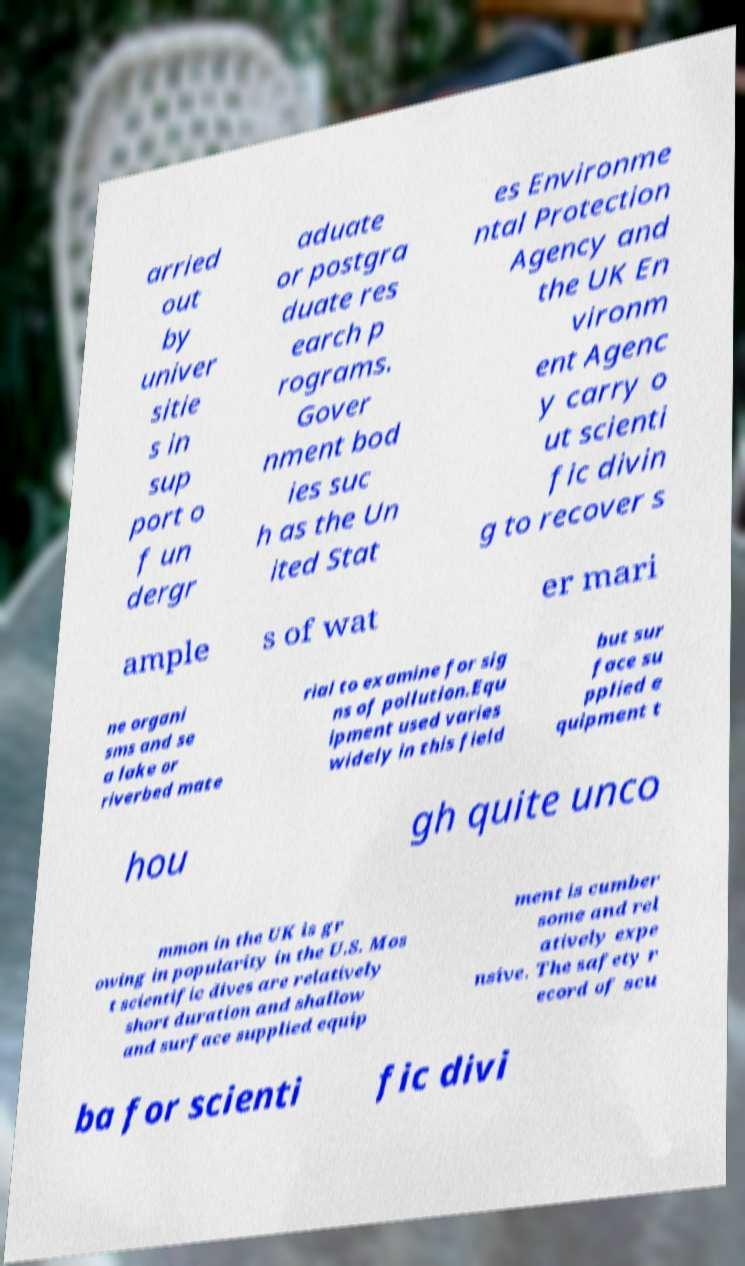Can you read and provide the text displayed in the image?This photo seems to have some interesting text. Can you extract and type it out for me? arried out by univer sitie s in sup port o f un dergr aduate or postgra duate res earch p rograms. Gover nment bod ies suc h as the Un ited Stat es Environme ntal Protection Agency and the UK En vironm ent Agenc y carry o ut scienti fic divin g to recover s ample s of wat er mari ne organi sms and se a lake or riverbed mate rial to examine for sig ns of pollution.Equ ipment used varies widely in this field but sur face su pplied e quipment t hou gh quite unco mmon in the UK is gr owing in popularity in the U.S. Mos t scientific dives are relatively short duration and shallow and surface supplied equip ment is cumber some and rel atively expe nsive. The safety r ecord of scu ba for scienti fic divi 